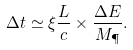<formula> <loc_0><loc_0><loc_500><loc_500>\Delta t \simeq \xi \frac { L } { c } \times \frac { \Delta E } { M _ { \P } } .</formula> 